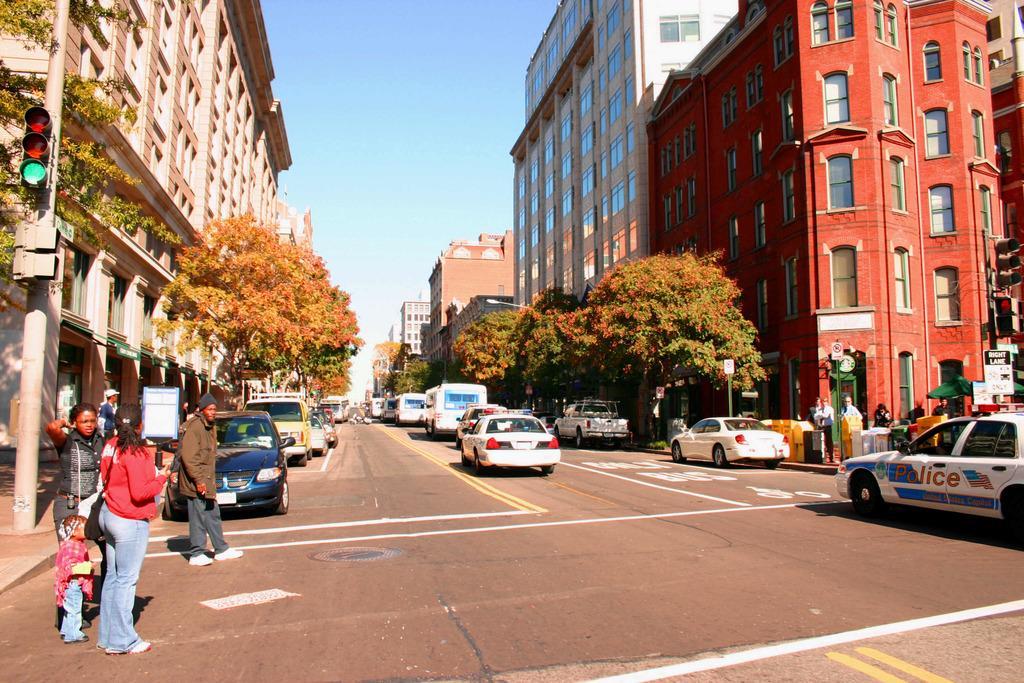Describe this image in one or two sentences. This is an outside view. At the bottom there are many vehicles on the road. Beside the road few people are standing. On both sides of the road there are many buildings and trees. On the left side there is a traffic signal pole on the footpath. At the top of the image I can see the sky. 